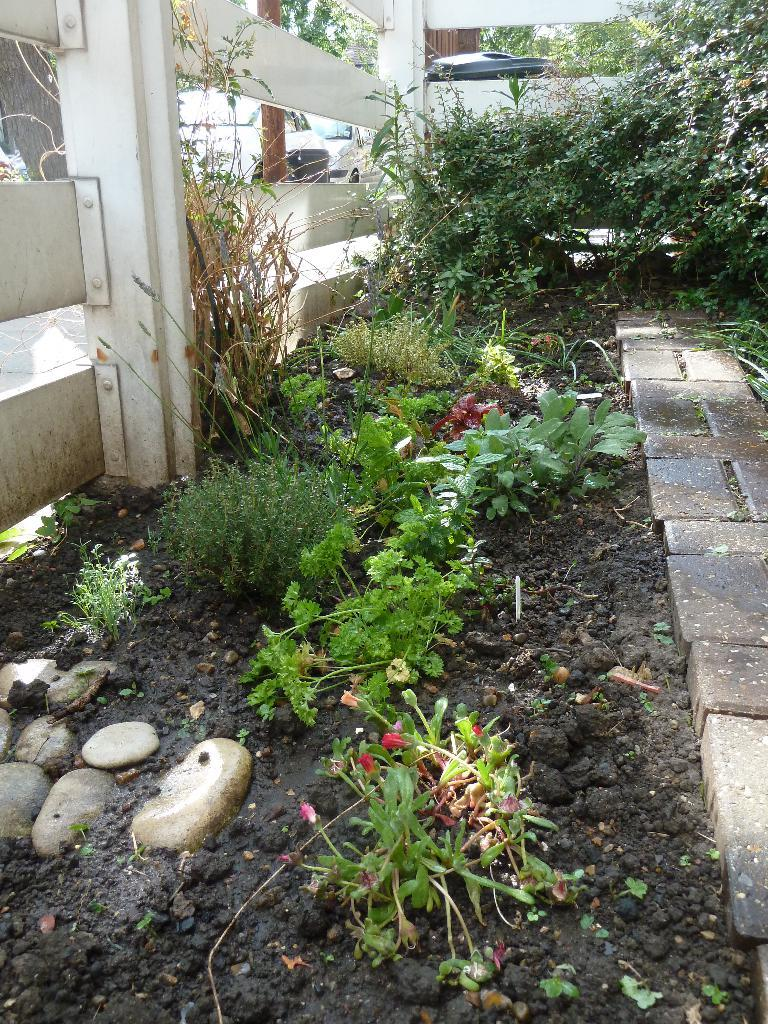What colors are the flowers in the image? The flowers in the image are in red, orange, and purple colors. What color are the plants in the image? The plants in the image are in green color. What is the purpose of the fencing visible in the image? The purpose of the fencing is not specified in the image, but it could be for enclosing or separating areas. What can be seen in the background of the image? There are vehicles visible in the background of the image. What time does the clock show in the image? There is no clock present in the image. What type of ground is visible in the image? The type of ground is not specified in the image; it could be grass, dirt, or another surface. 